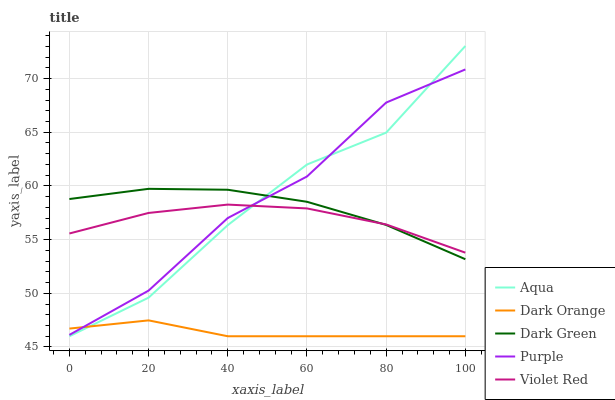Does Dark Orange have the minimum area under the curve?
Answer yes or no. Yes. Does Purple have the maximum area under the curve?
Answer yes or no. Yes. Does Violet Red have the minimum area under the curve?
Answer yes or no. No. Does Violet Red have the maximum area under the curve?
Answer yes or no. No. Is Dark Orange the smoothest?
Answer yes or no. Yes. Is Purple the roughest?
Answer yes or no. Yes. Is Violet Red the smoothest?
Answer yes or no. No. Is Violet Red the roughest?
Answer yes or no. No. Does Violet Red have the lowest value?
Answer yes or no. No. Does Aqua have the highest value?
Answer yes or no. Yes. Does Violet Red have the highest value?
Answer yes or no. No. Is Dark Orange less than Dark Green?
Answer yes or no. Yes. Is Violet Red greater than Dark Orange?
Answer yes or no. Yes. Does Purple intersect Aqua?
Answer yes or no. Yes. Is Purple less than Aqua?
Answer yes or no. No. Is Purple greater than Aqua?
Answer yes or no. No. Does Dark Orange intersect Dark Green?
Answer yes or no. No. 